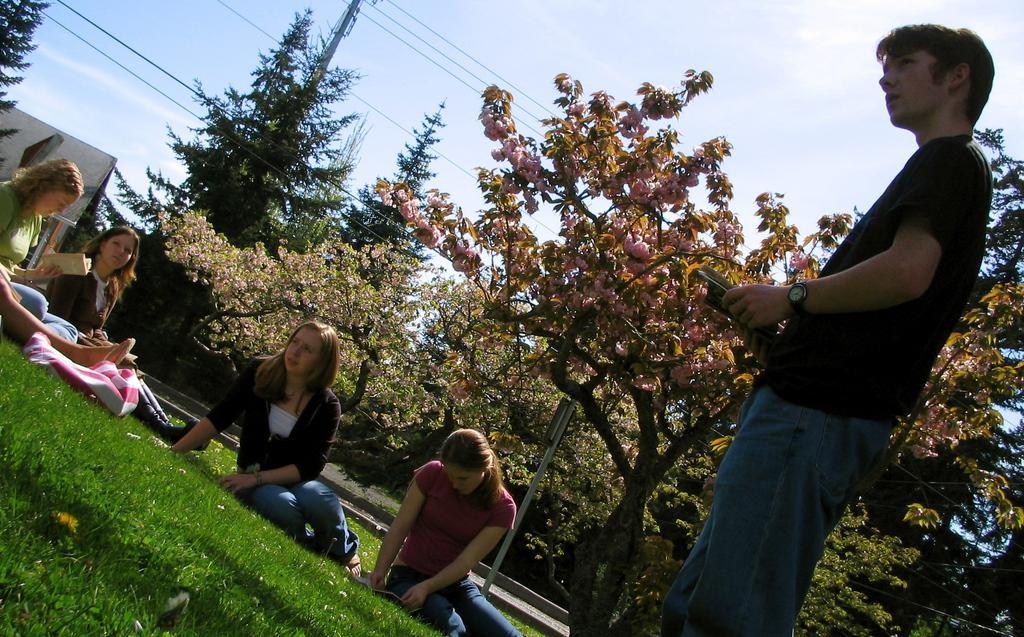How would you summarize this image in a sentence or two? In this image on the right side, I can see a man standing. On the left side I can see some people are sitting on the grass. In the in the background, I can see the trees and clouds in the sky. 